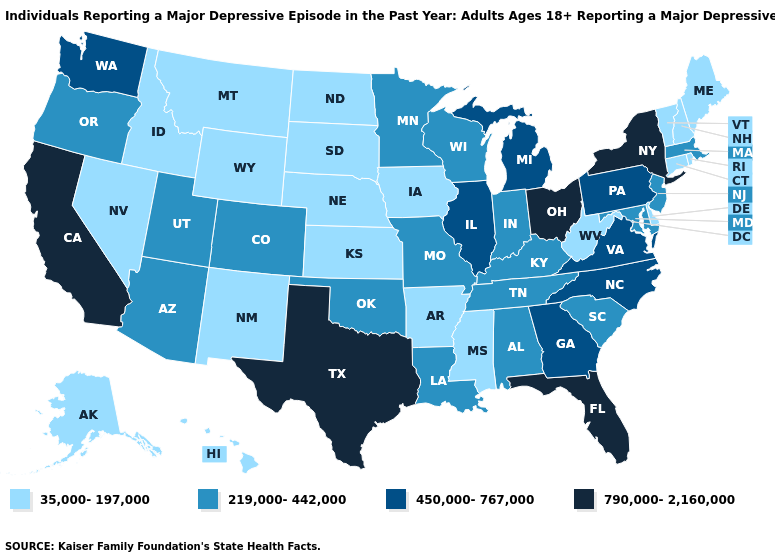Name the states that have a value in the range 219,000-442,000?
Concise answer only. Alabama, Arizona, Colorado, Indiana, Kentucky, Louisiana, Maryland, Massachusetts, Minnesota, Missouri, New Jersey, Oklahoma, Oregon, South Carolina, Tennessee, Utah, Wisconsin. Does Oklahoma have the same value as Massachusetts?
Short answer required. Yes. What is the highest value in the USA?
Concise answer only. 790,000-2,160,000. Name the states that have a value in the range 450,000-767,000?
Answer briefly. Georgia, Illinois, Michigan, North Carolina, Pennsylvania, Virginia, Washington. What is the value of Oklahoma?
Quick response, please. 219,000-442,000. Among the states that border Mississippi , does Louisiana have the lowest value?
Quick response, please. No. Name the states that have a value in the range 790,000-2,160,000?
Answer briefly. California, Florida, New York, Ohio, Texas. Name the states that have a value in the range 219,000-442,000?
Give a very brief answer. Alabama, Arizona, Colorado, Indiana, Kentucky, Louisiana, Maryland, Massachusetts, Minnesota, Missouri, New Jersey, Oklahoma, Oregon, South Carolina, Tennessee, Utah, Wisconsin. What is the value of West Virginia?
Be succinct. 35,000-197,000. Among the states that border New Jersey , does Delaware have the highest value?
Quick response, please. No. What is the value of North Carolina?
Quick response, please. 450,000-767,000. Does Florida have the highest value in the South?
Short answer required. Yes. What is the value of Utah?
Answer briefly. 219,000-442,000. What is the value of Wisconsin?
Be succinct. 219,000-442,000. Name the states that have a value in the range 450,000-767,000?
Write a very short answer. Georgia, Illinois, Michigan, North Carolina, Pennsylvania, Virginia, Washington. 